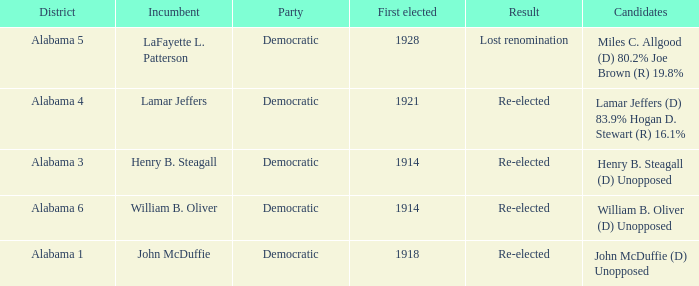What kind of party is the district in Alabama 1? Democratic. 